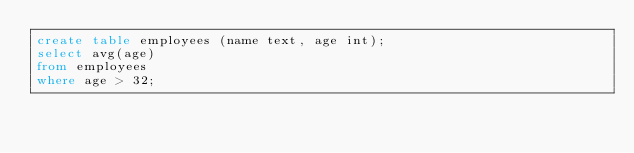<code> <loc_0><loc_0><loc_500><loc_500><_SQL_>create table employees (name text, age int);
select avg(age)
from employees
where age > 32;
</code> 